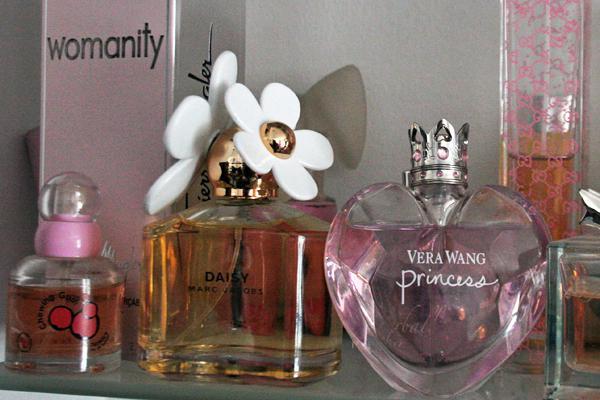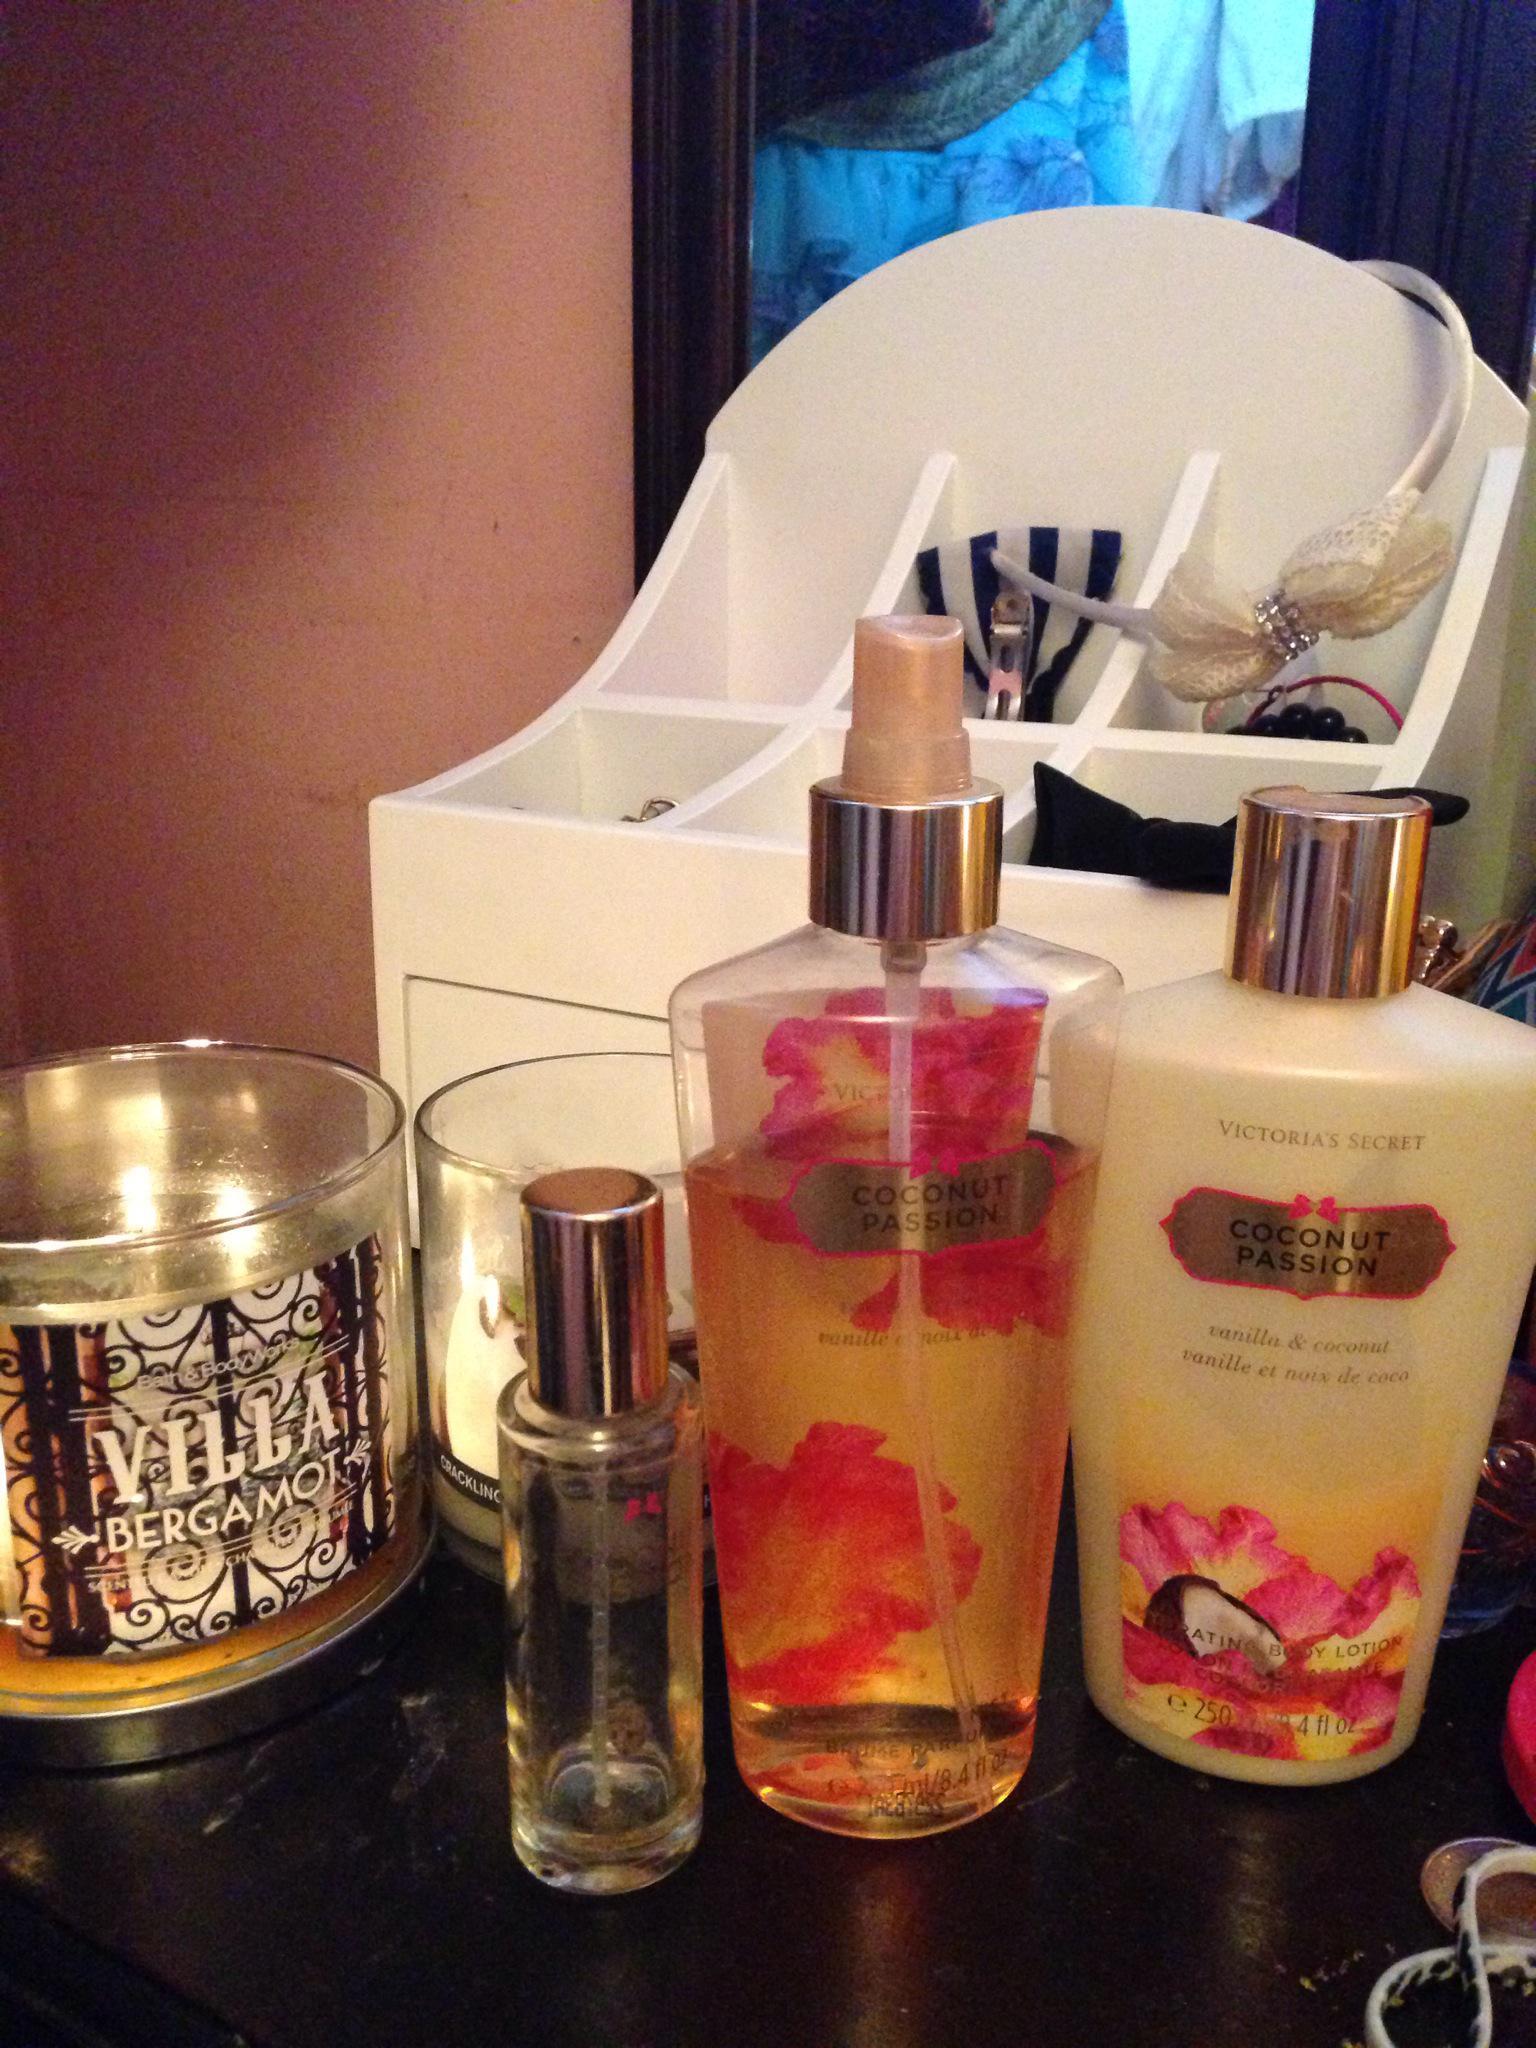The first image is the image on the left, the second image is the image on the right. Analyze the images presented: Is the assertion "Every image has more than nine fragrances." valid? Answer yes or no. No. The first image is the image on the left, the second image is the image on the right. For the images shown, is this caption "A heart-shaped clear glass bottle is in the front of a grouping of different fragrance bottles." true? Answer yes or no. Yes. 